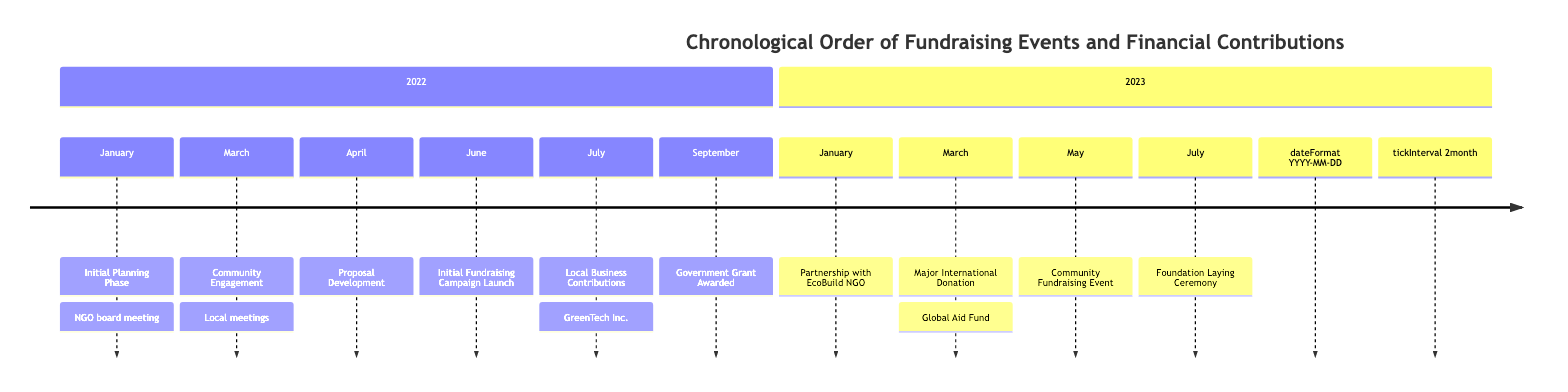What event took place on March 5, 2022? According to the timeline, the event listed for March 5, 2022, is "Community Engagement," where the NGO organized meetings with local communities to understand their needs.
Answer: Community Engagement How many fundraising events are listed in the timeline? By counting each distinct fundraising event on the timeline, we can see that there are four specific events related to fundraising: "Initial Fundraising Campaign Launch," "Community Fundraising Event," "Local Business Contributions," and "Major International Donation."
Answer: 4 What was the date of the Government Grant Awarded event? The timeline displays that the Government Grant Awarded event occurred on September 10, 2022.
Answer: September 10, 2022 Which organization contributed a significant donation in March 2023? The timeline indicates that the significant donation received in March 2023 was from the "Global Aid Fund" international foundation.
Answer: Global Aid Fund What event happened first according to the timeline? By reviewing the events in chronological order, we find that the first event is the "Initial Planning Phase," occurring on January 15, 2022.
Answer: Initial Planning Phase What is the last event listed in the timeline? The last event in the timeline is the "Foundation Laying Ceremony," which took place on July 5, 2023.
Answer: Foundation Laying Ceremony Between which two events did the Local Business Contributions occur, based on the timeline? Looking at the timeline, the Local Business Contributions event occurred after the "Initial Fundraising Campaign Launch" (June 1, 2022) and before the "Government Grant Awarded" (September 10, 2022).
Answer: Initial Fundraising Campaign Launch and Government Grant Awarded What was established on January 15, 2023? The timeline shows that on January 15, 2023, a partnership with EcoBuild NGO was established.
Answer: Partnership with EcoBuild NGO 